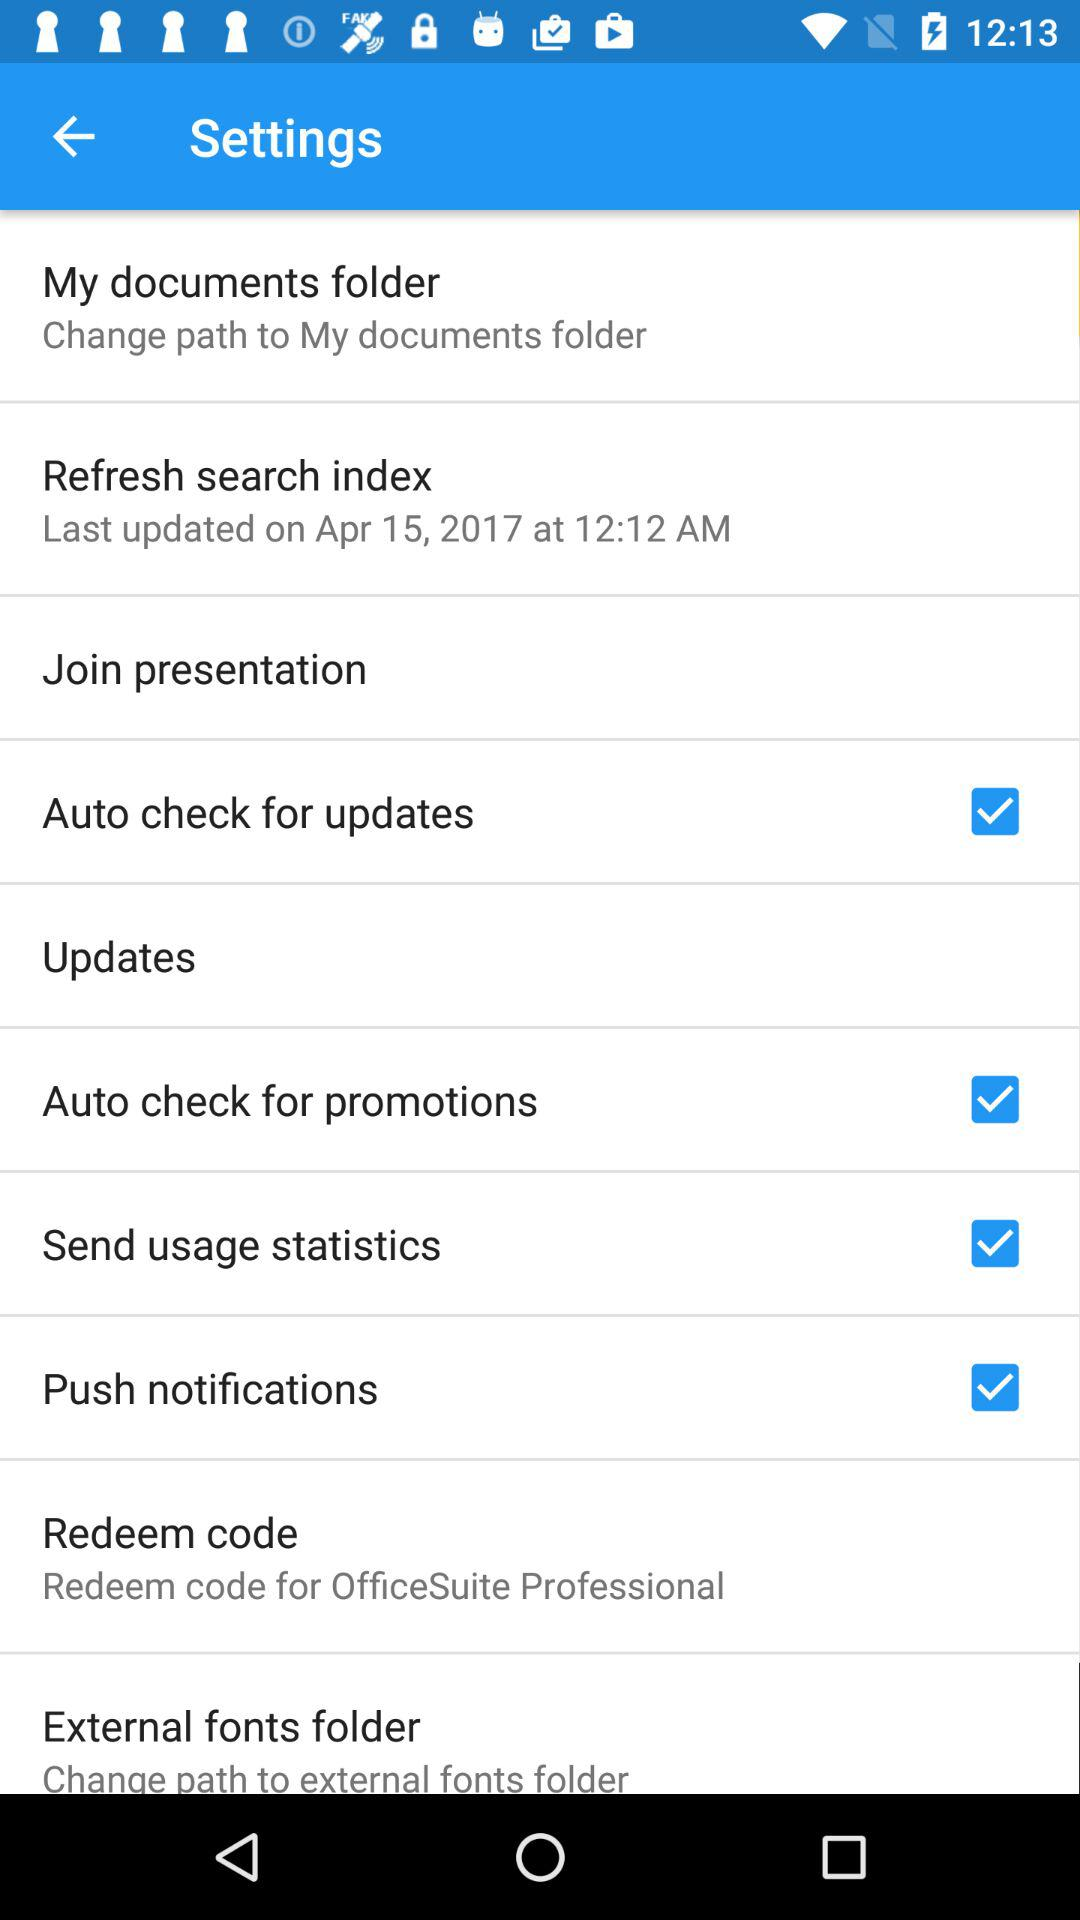What is the last updated date of the "Refresh search index"? The last updated date of the "Refresh search index" is April 15, 2017. 